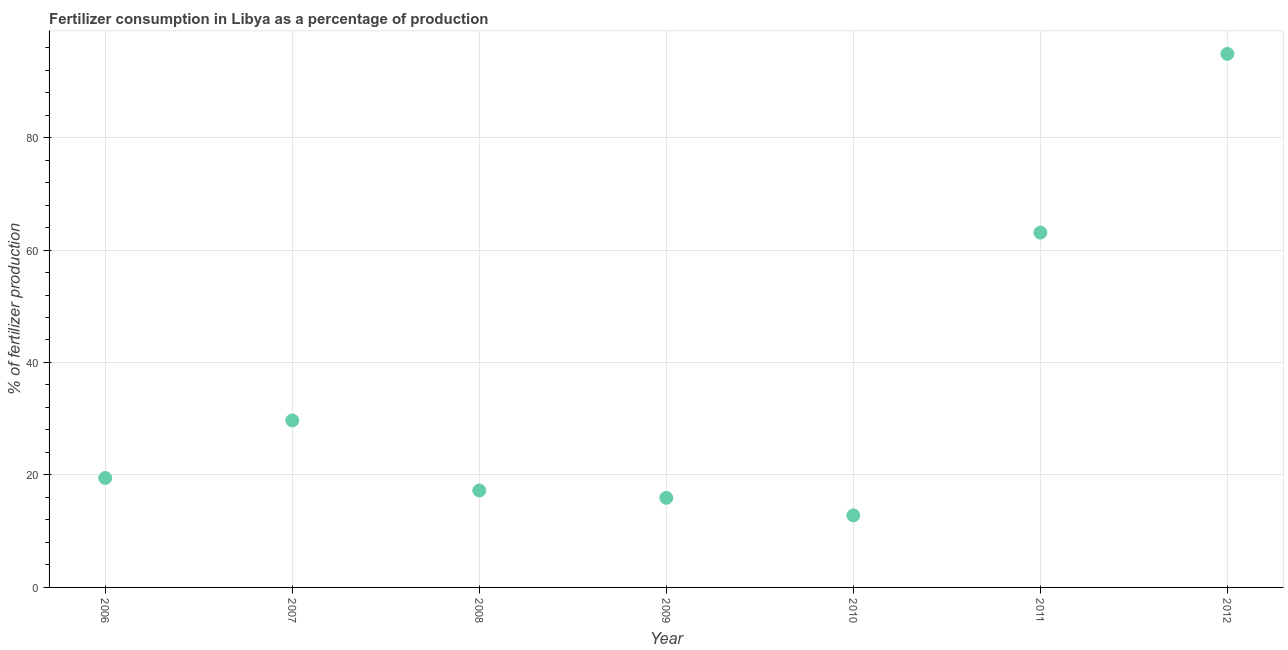What is the amount of fertilizer consumption in 2012?
Keep it short and to the point. 94.87. Across all years, what is the maximum amount of fertilizer consumption?
Your answer should be compact. 94.87. Across all years, what is the minimum amount of fertilizer consumption?
Make the answer very short. 12.81. In which year was the amount of fertilizer consumption minimum?
Your response must be concise. 2010. What is the sum of the amount of fertilizer consumption?
Your answer should be compact. 253.09. What is the difference between the amount of fertilizer consumption in 2007 and 2010?
Provide a short and direct response. 16.89. What is the average amount of fertilizer consumption per year?
Your answer should be compact. 36.16. What is the median amount of fertilizer consumption?
Your response must be concise. 19.46. What is the ratio of the amount of fertilizer consumption in 2010 to that in 2012?
Your answer should be very brief. 0.14. Is the amount of fertilizer consumption in 2009 less than that in 2010?
Provide a succinct answer. No. Is the difference between the amount of fertilizer consumption in 2006 and 2007 greater than the difference between any two years?
Keep it short and to the point. No. What is the difference between the highest and the second highest amount of fertilizer consumption?
Offer a very short reply. 31.78. Is the sum of the amount of fertilizer consumption in 2008 and 2012 greater than the maximum amount of fertilizer consumption across all years?
Ensure brevity in your answer.  Yes. What is the difference between the highest and the lowest amount of fertilizer consumption?
Keep it short and to the point. 82.07. In how many years, is the amount of fertilizer consumption greater than the average amount of fertilizer consumption taken over all years?
Provide a succinct answer. 2. Does the amount of fertilizer consumption monotonically increase over the years?
Keep it short and to the point. No. How many dotlines are there?
Make the answer very short. 1. How many years are there in the graph?
Provide a succinct answer. 7. What is the title of the graph?
Give a very brief answer. Fertilizer consumption in Libya as a percentage of production. What is the label or title of the X-axis?
Give a very brief answer. Year. What is the label or title of the Y-axis?
Keep it short and to the point. % of fertilizer production. What is the % of fertilizer production in 2006?
Your response must be concise. 19.46. What is the % of fertilizer production in 2007?
Provide a short and direct response. 29.69. What is the % of fertilizer production in 2008?
Offer a very short reply. 17.23. What is the % of fertilizer production in 2009?
Provide a succinct answer. 15.92. What is the % of fertilizer production in 2010?
Keep it short and to the point. 12.81. What is the % of fertilizer production in 2011?
Provide a short and direct response. 63.1. What is the % of fertilizer production in 2012?
Your answer should be compact. 94.87. What is the difference between the % of fertilizer production in 2006 and 2007?
Offer a very short reply. -10.23. What is the difference between the % of fertilizer production in 2006 and 2008?
Your response must be concise. 2.23. What is the difference between the % of fertilizer production in 2006 and 2009?
Give a very brief answer. 3.54. What is the difference between the % of fertilizer production in 2006 and 2010?
Keep it short and to the point. 6.65. What is the difference between the % of fertilizer production in 2006 and 2011?
Make the answer very short. -43.63. What is the difference between the % of fertilizer production in 2006 and 2012?
Provide a succinct answer. -75.41. What is the difference between the % of fertilizer production in 2007 and 2008?
Ensure brevity in your answer.  12.46. What is the difference between the % of fertilizer production in 2007 and 2009?
Offer a terse response. 13.77. What is the difference between the % of fertilizer production in 2007 and 2010?
Ensure brevity in your answer.  16.89. What is the difference between the % of fertilizer production in 2007 and 2011?
Your answer should be very brief. -33.4. What is the difference between the % of fertilizer production in 2007 and 2012?
Ensure brevity in your answer.  -65.18. What is the difference between the % of fertilizer production in 2008 and 2009?
Keep it short and to the point. 1.31. What is the difference between the % of fertilizer production in 2008 and 2010?
Provide a succinct answer. 4.42. What is the difference between the % of fertilizer production in 2008 and 2011?
Your answer should be very brief. -45.86. What is the difference between the % of fertilizer production in 2008 and 2012?
Offer a very short reply. -77.64. What is the difference between the % of fertilizer production in 2009 and 2010?
Make the answer very short. 3.12. What is the difference between the % of fertilizer production in 2009 and 2011?
Ensure brevity in your answer.  -47.17. What is the difference between the % of fertilizer production in 2009 and 2012?
Keep it short and to the point. -78.95. What is the difference between the % of fertilizer production in 2010 and 2011?
Keep it short and to the point. -50.29. What is the difference between the % of fertilizer production in 2010 and 2012?
Make the answer very short. -82.07. What is the difference between the % of fertilizer production in 2011 and 2012?
Your answer should be very brief. -31.78. What is the ratio of the % of fertilizer production in 2006 to that in 2007?
Your answer should be very brief. 0.66. What is the ratio of the % of fertilizer production in 2006 to that in 2008?
Provide a succinct answer. 1.13. What is the ratio of the % of fertilizer production in 2006 to that in 2009?
Your response must be concise. 1.22. What is the ratio of the % of fertilizer production in 2006 to that in 2010?
Provide a succinct answer. 1.52. What is the ratio of the % of fertilizer production in 2006 to that in 2011?
Your response must be concise. 0.31. What is the ratio of the % of fertilizer production in 2006 to that in 2012?
Your response must be concise. 0.2. What is the ratio of the % of fertilizer production in 2007 to that in 2008?
Give a very brief answer. 1.72. What is the ratio of the % of fertilizer production in 2007 to that in 2009?
Your answer should be compact. 1.86. What is the ratio of the % of fertilizer production in 2007 to that in 2010?
Offer a terse response. 2.32. What is the ratio of the % of fertilizer production in 2007 to that in 2011?
Make the answer very short. 0.47. What is the ratio of the % of fertilizer production in 2007 to that in 2012?
Offer a terse response. 0.31. What is the ratio of the % of fertilizer production in 2008 to that in 2009?
Offer a terse response. 1.08. What is the ratio of the % of fertilizer production in 2008 to that in 2010?
Your response must be concise. 1.34. What is the ratio of the % of fertilizer production in 2008 to that in 2011?
Provide a short and direct response. 0.27. What is the ratio of the % of fertilizer production in 2008 to that in 2012?
Give a very brief answer. 0.18. What is the ratio of the % of fertilizer production in 2009 to that in 2010?
Offer a very short reply. 1.24. What is the ratio of the % of fertilizer production in 2009 to that in 2011?
Offer a terse response. 0.25. What is the ratio of the % of fertilizer production in 2009 to that in 2012?
Offer a very short reply. 0.17. What is the ratio of the % of fertilizer production in 2010 to that in 2011?
Make the answer very short. 0.2. What is the ratio of the % of fertilizer production in 2010 to that in 2012?
Provide a short and direct response. 0.14. What is the ratio of the % of fertilizer production in 2011 to that in 2012?
Keep it short and to the point. 0.67. 